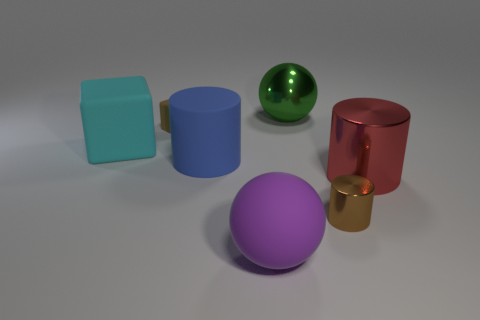What color is the big matte thing that is in front of the red shiny cylinder?
Give a very brief answer. Purple. Is the number of tiny brown things in front of the big red shiny object greater than the number of tiny green matte spheres?
Ensure brevity in your answer.  Yes. What is the color of the large shiny cylinder?
Your answer should be very brief. Red. There is a brown thing on the right side of the ball in front of the large cylinder that is in front of the matte cylinder; what shape is it?
Ensure brevity in your answer.  Cylinder. What is the object that is behind the big rubber cube and left of the large blue object made of?
Make the answer very short. Rubber. There is a big object that is right of the big sphere on the right side of the purple rubber ball; what shape is it?
Your answer should be compact. Cylinder. Is there any other thing that has the same color as the large metal sphere?
Your response must be concise. No. Does the blue thing have the same size as the ball on the left side of the large green thing?
Offer a terse response. Yes. How many tiny objects are either brown metal things or yellow metallic cubes?
Provide a short and direct response. 1. Are there more large rubber blocks than metal things?
Offer a terse response. No. 